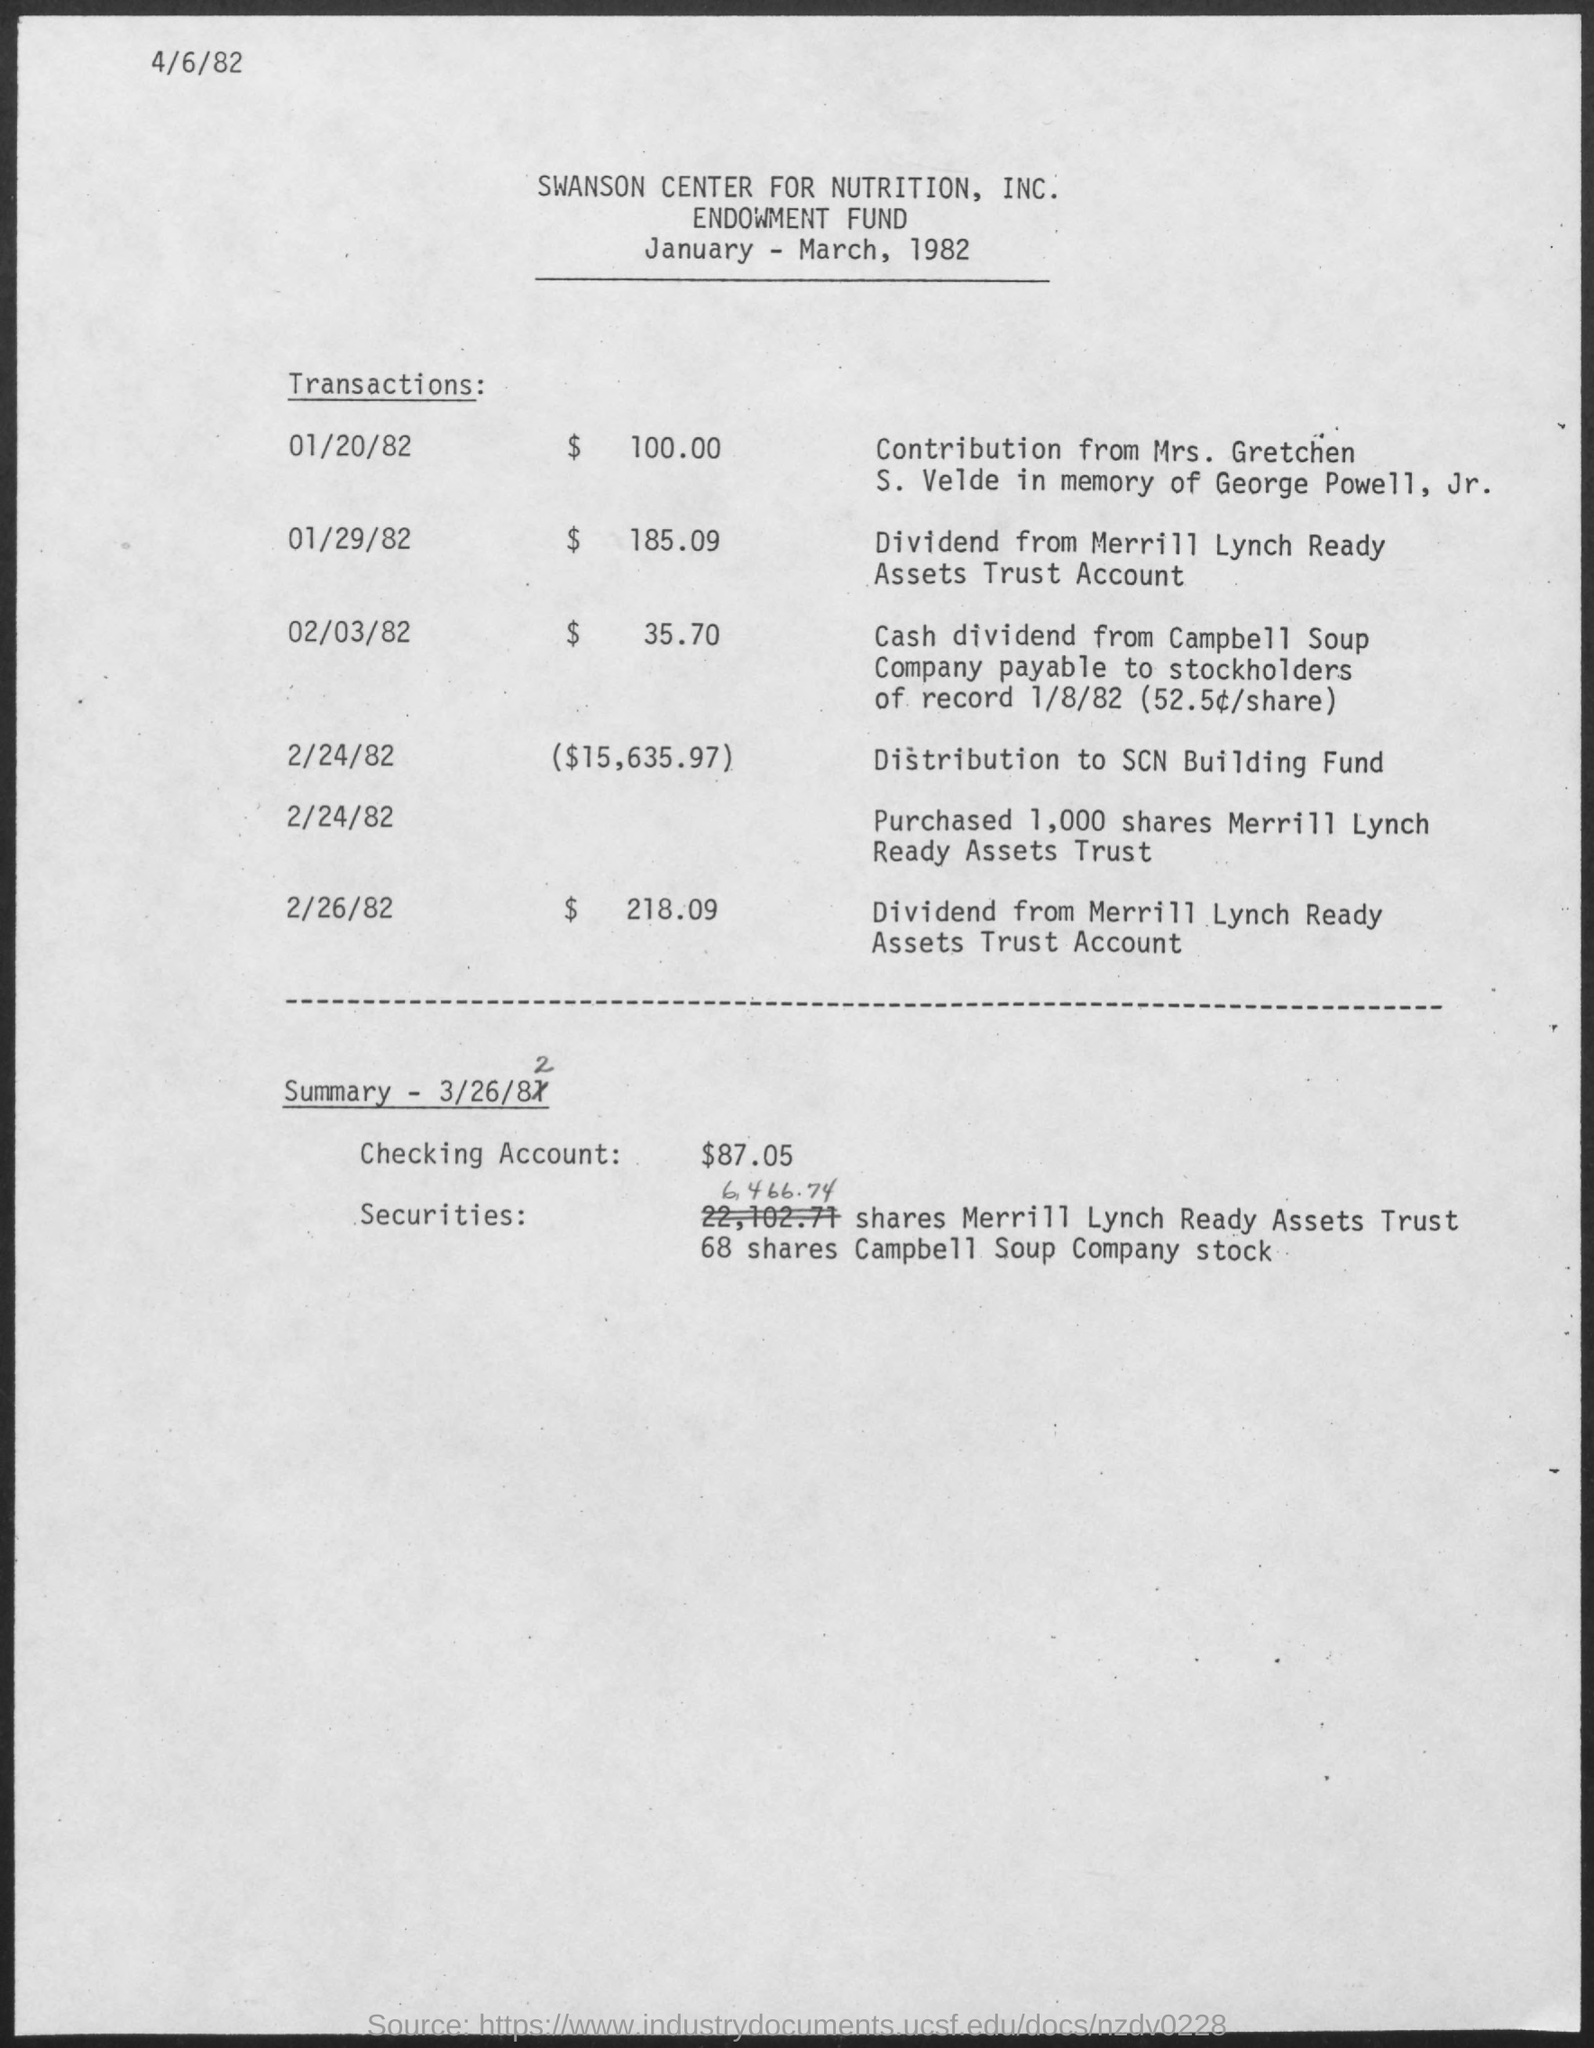What is the $ for transaction on 01/20/82?
Your answer should be very brief. 100.00. What is the $ for transaction on 01/29/82?
Your answer should be very brief. 185.09. What is the $ for transaction on 02/03/82?
Provide a short and direct response. $ 35.70. What is the $ for transaction on 2/24/82?
Offer a very short reply. 15,635.97. What is the $ for transaction on 2/26/82?
Make the answer very short. $ 218.09. What is the summary date?
Keep it short and to the point. 3/26/82. What is the Checking Account amount?
Ensure brevity in your answer.  $87.05. 